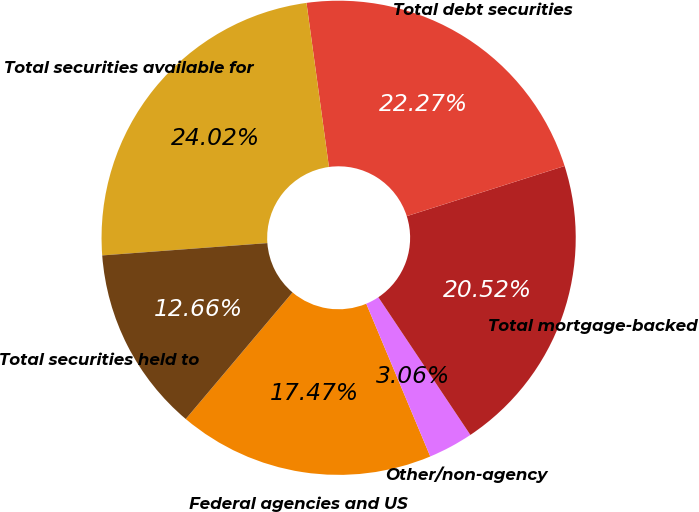<chart> <loc_0><loc_0><loc_500><loc_500><pie_chart><fcel>Federal agencies and US<fcel>Other/non-agency<fcel>Total mortgage-backed<fcel>Total debt securities<fcel>Total securities available for<fcel>Total securities held to<nl><fcel>17.47%<fcel>3.06%<fcel>20.52%<fcel>22.27%<fcel>24.02%<fcel>12.66%<nl></chart> 